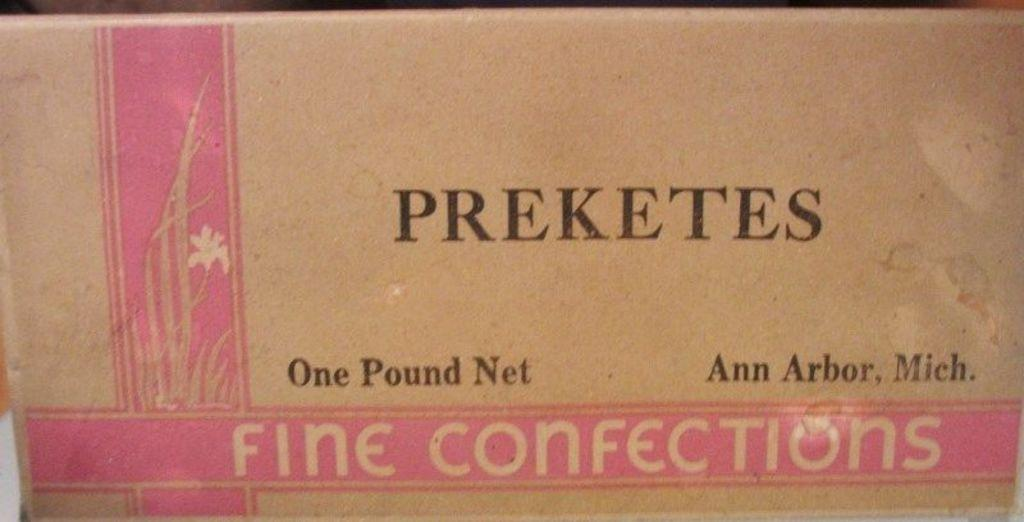<image>
Provide a brief description of the given image. A one pound box of fine confections from Ann Arbor Michigan. 